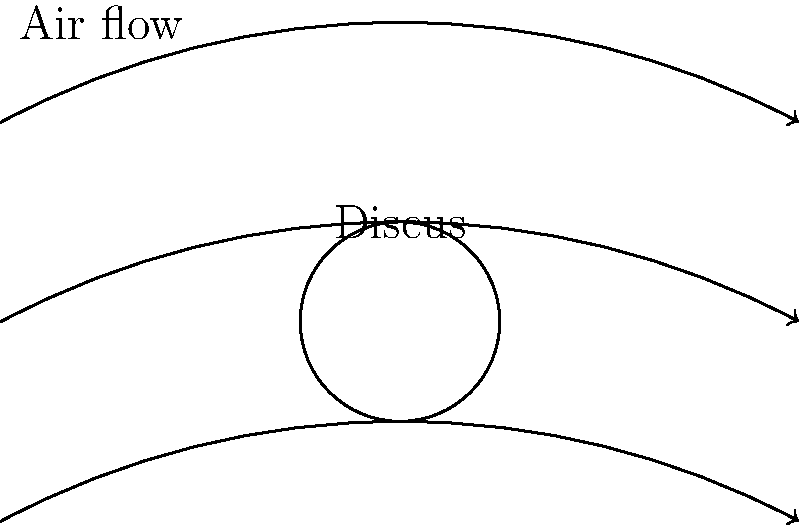As a former discus thrower, you understand the importance of aerodynamics in achieving maximum distance. Consider the diagram showing the air flow patterns around a discus in flight. What is the primary aerodynamic force acting on the discus that helps it maintain its trajectory, and how does the discus's rotation contribute to this force? To understand the aerodynamics of a discus throw, let's break it down step-by-step:

1. Air flow pattern: The diagram shows air flowing smoothly over the top and bottom surfaces of the discus, with a slight upward deflection of air above the discus.

2. Pressure difference: This air flow pattern creates a pressure difference between the top and bottom surfaces of the discus. The air moving over the top surface has a longer path and thus moves faster, resulting in lower pressure compared to the bottom surface.

3. Lift force: The pressure difference generates an upward force called lift, perpendicular to the direction of motion. This is the primary aerodynamic force helping the discus maintain its trajectory.

4. Rotation contribution: The discus's rotation, typically at about 5-10 revolutions per second, creates a gyroscopic effect that stabilizes its flight path. This rotation also contributes to the lift force through the Magnus effect.

5. Magnus effect: As the discus rotates, it drags some air around with it. This creates a thin layer of air moving with the discus, effectively changing its shape as seen by the oncoming air. This asymmetry in the air flow enhances the pressure difference and increases lift.

6. Angle of attack: The discus is typically thrown at a slight angle to the horizontal (angle of attack). This angle, combined with the rotation and air flow, optimizes the lift force for maximum distance.

The combination of these factors - the discus's shape, its rotation, and its angle of attack - all contribute to generating the lift force that helps maintain its trajectory and achieve maximum distance in flight.
Answer: Lift force, enhanced by rotation-induced Magnus effect 